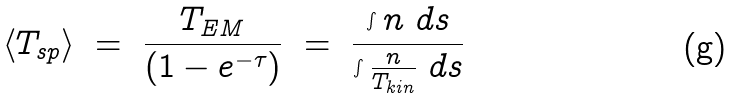<formula> <loc_0><loc_0><loc_500><loc_500>\left < T _ { s p } \right > \ = \ \frac { T _ { E M } } { \left ( 1 - e ^ { - \tau } \right ) } \ = \ \frac { \int { n \ d s } } { \int { \frac { n } { T _ { k i n } } \ d s } }</formula> 